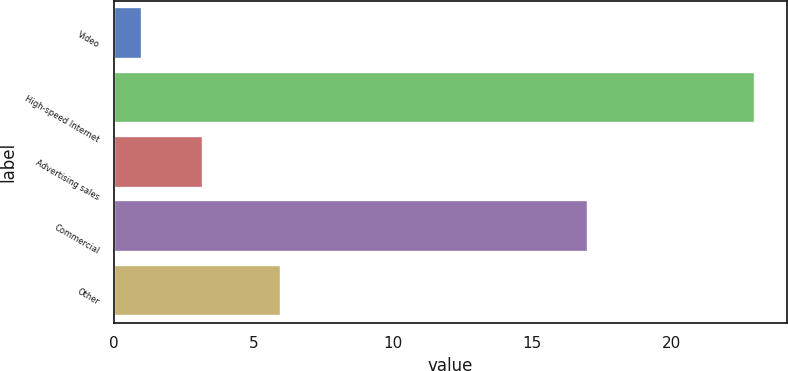Convert chart. <chart><loc_0><loc_0><loc_500><loc_500><bar_chart><fcel>Video<fcel>High-speed Internet<fcel>Advertising sales<fcel>Commercial<fcel>Other<nl><fcel>1<fcel>23<fcel>3.2<fcel>17<fcel>6<nl></chart> 